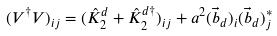<formula> <loc_0><loc_0><loc_500><loc_500>( V ^ { \dagger } V ) _ { i j } = ( \hat { K } ^ { d } _ { 2 } + \hat { K } _ { 2 } ^ { d \dagger } ) _ { i j } + a ^ { 2 } ( \vec { b } _ { d } ) _ { i } ( \vec { b } _ { d } ) _ { j } ^ { * }</formula> 